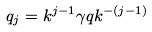<formula> <loc_0><loc_0><loc_500><loc_500>q _ { j } = k ^ { j - 1 } \gamma q k ^ { - ( j - 1 ) }</formula> 